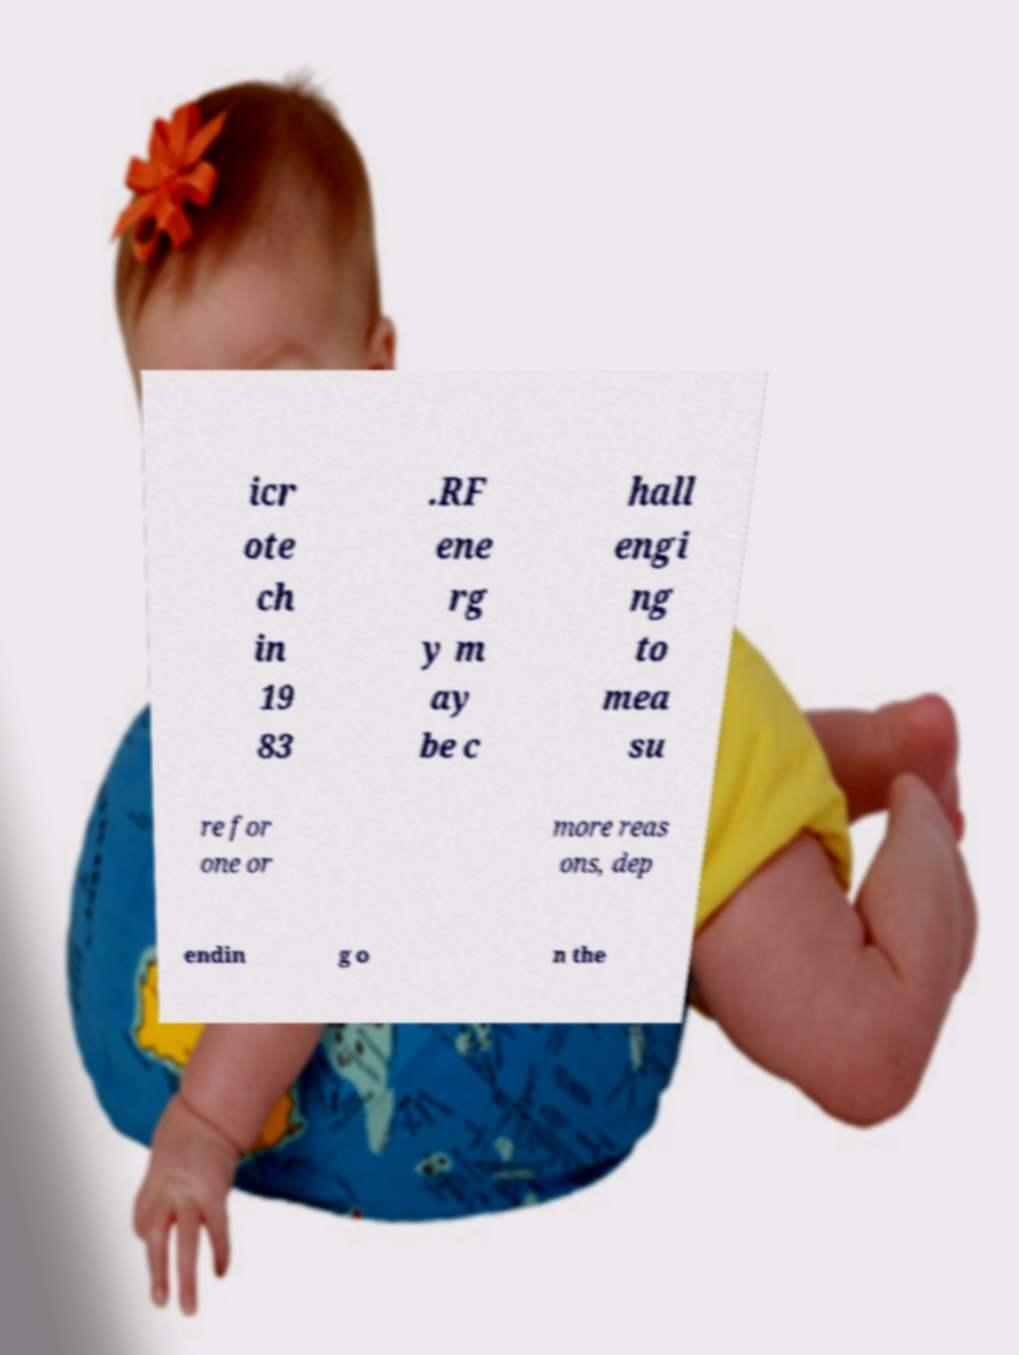There's text embedded in this image that I need extracted. Can you transcribe it verbatim? icr ote ch in 19 83 .RF ene rg y m ay be c hall engi ng to mea su re for one or more reas ons, dep endin g o n the 